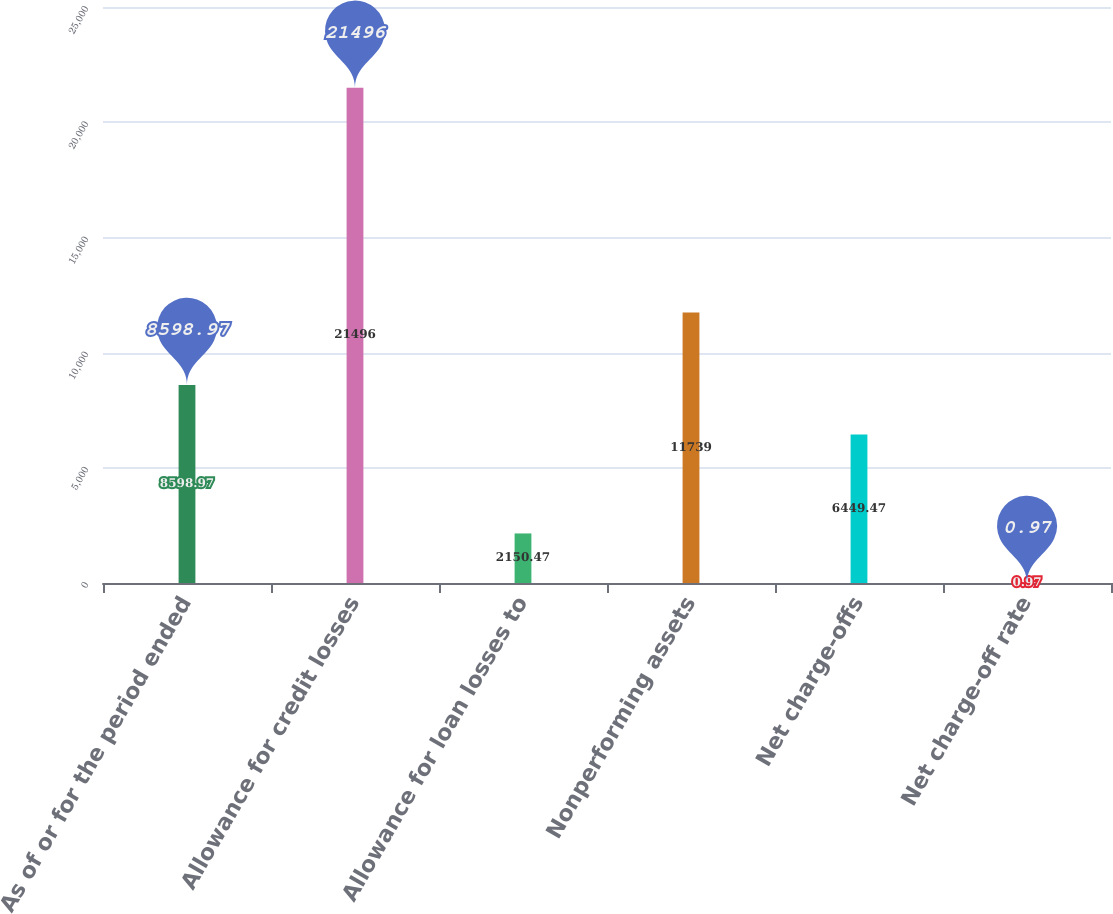Convert chart. <chart><loc_0><loc_0><loc_500><loc_500><bar_chart><fcel>As of or for the period ended<fcel>Allowance for credit losses<fcel>Allowance for loan losses to<fcel>Nonperforming assets<fcel>Net charge-offs<fcel>Net charge-off rate<nl><fcel>8598.97<fcel>21496<fcel>2150.47<fcel>11739<fcel>6449.47<fcel>0.97<nl></chart> 